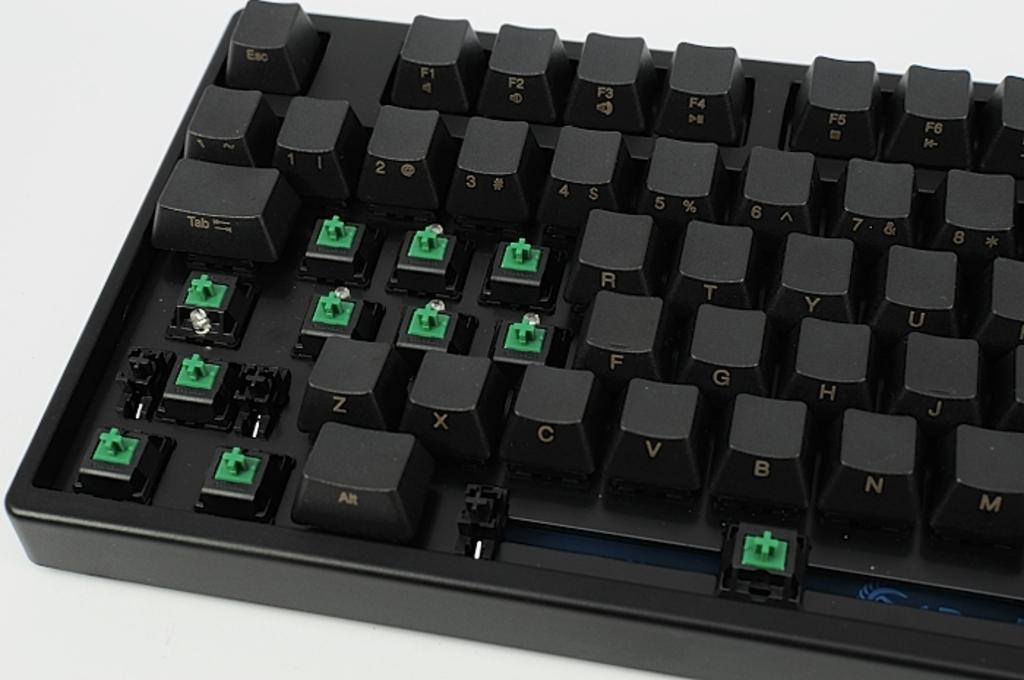What is the main object in the image? There is a keyboard in the image. What is the keyboard placed on? The keyboard is on a white color platform. Are all the keys present on the keyboard? No, some keys are missing from the keyboard. What street is the mother learning to drive on in the image? There is no street or mother present in the image; it only features a keyboard with missing keys. 